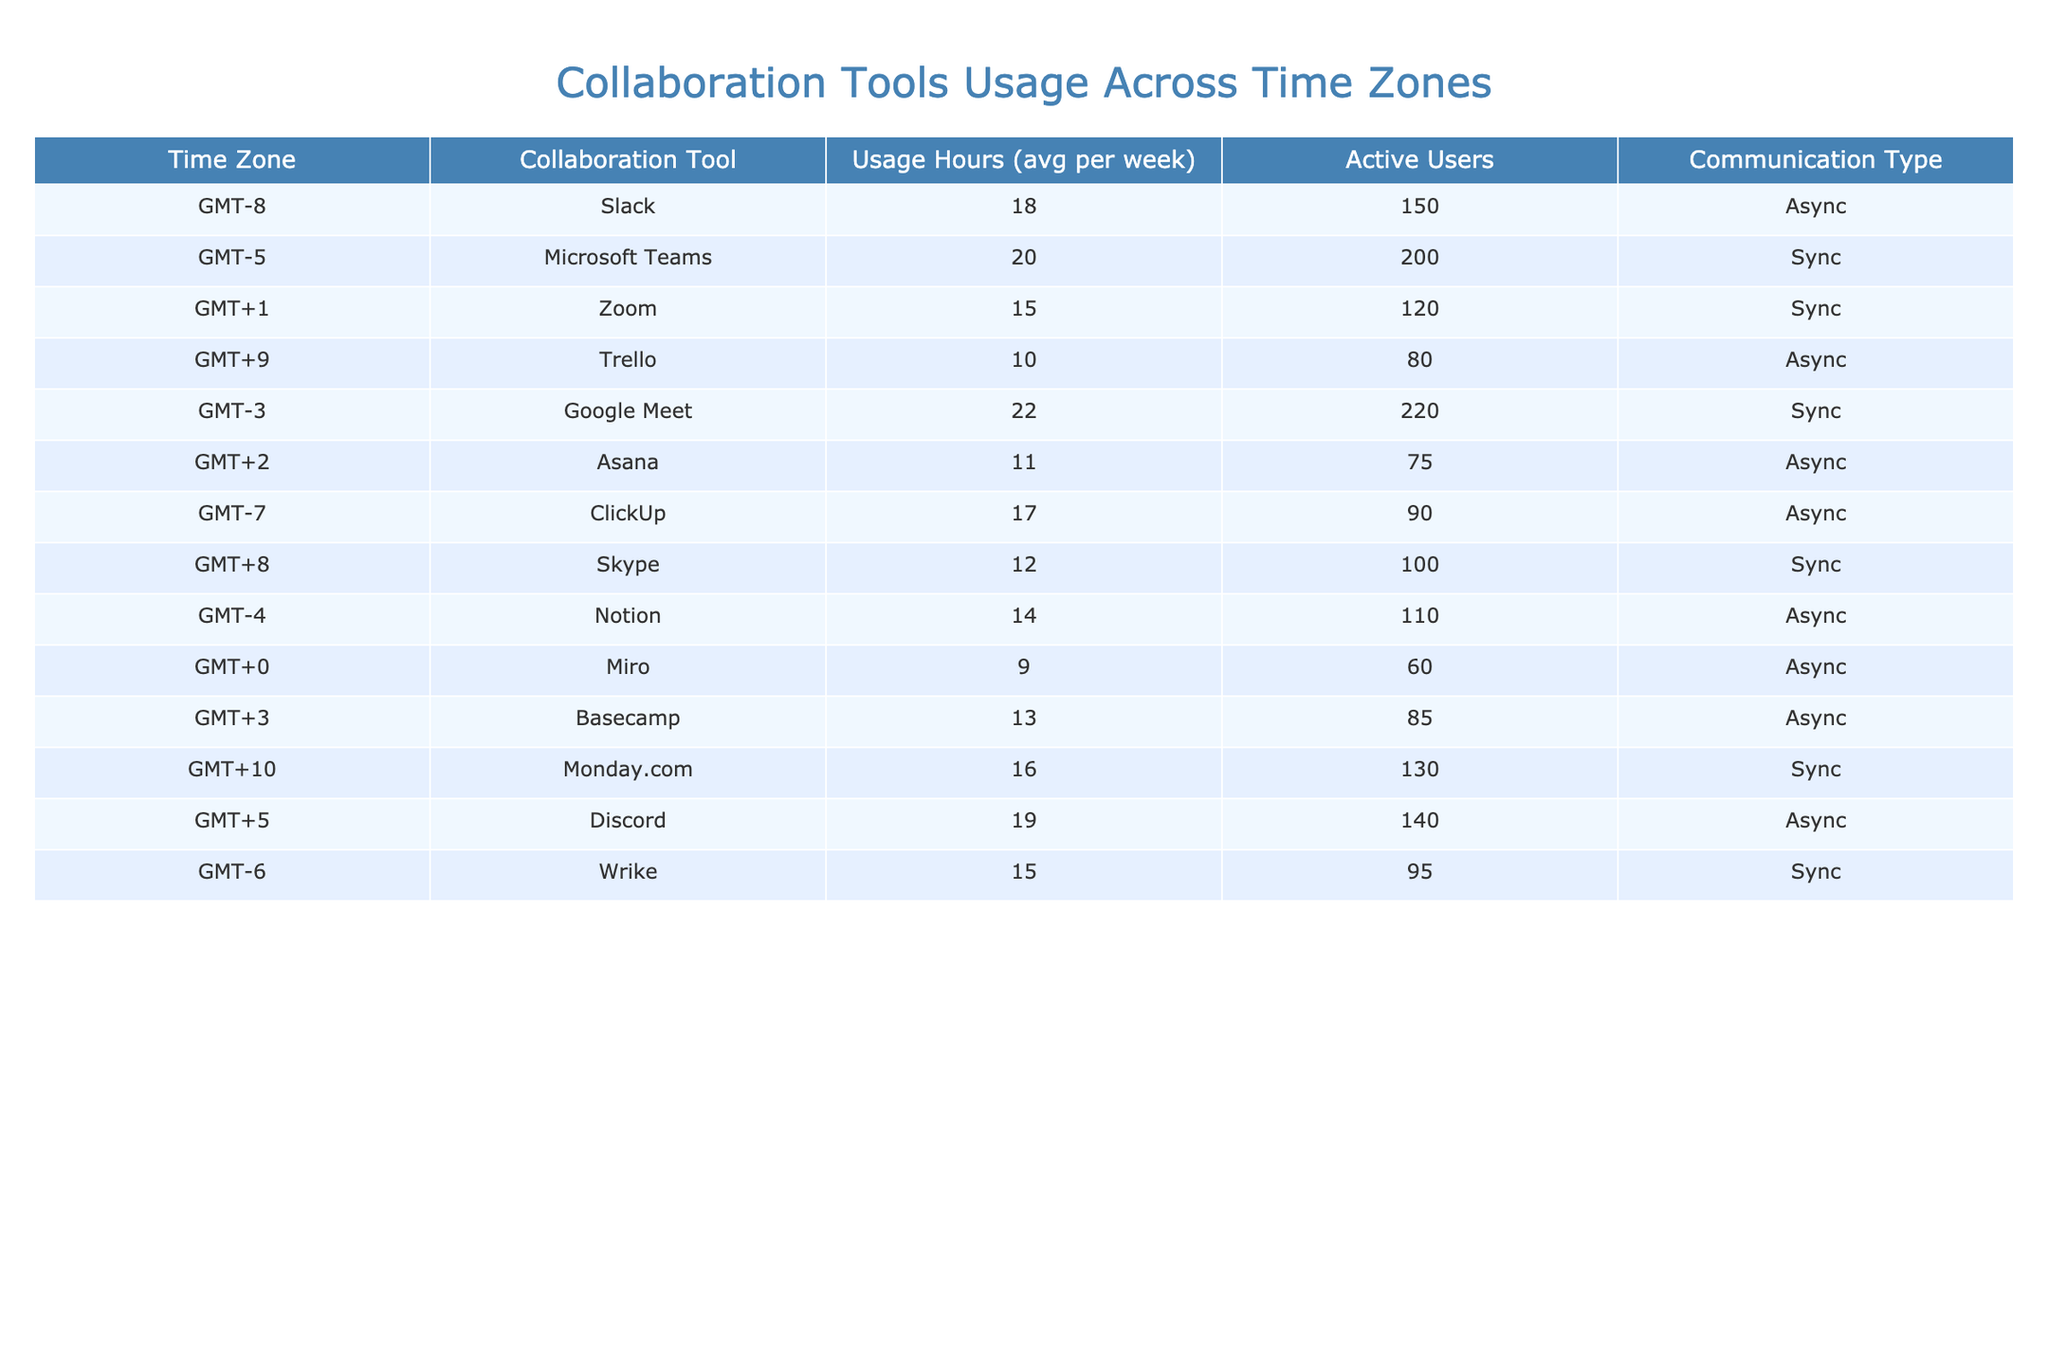What is the average usage hours for Slack in GMT-8? The table shows that the average usage hours for Slack in GMT-8 is listed as 18 hours per week.
Answer: 18 Which collaboration tool has the highest number of active users? By examining the "Active Users" column, Google Meet has the highest number of active users at 220.
Answer: Google Meet How many total active users are there for all collaboration tools in GMT-5 and GMT-3 combined? The total active users in GMT-5 (Microsoft Teams) is 200, and in GMT-3 (Google Meet) is 220. So, 200 + 220 = 420.
Answer: 420 Which time zone has the lowest average usage hours and what is that value? By reviewing the "Usage Hours" column, Miro in GMT+0 shows the lowest average usage at 9 hours per week.
Answer: 9 Is there a collaboration tool used in more than one time zone? Reviewing the "Collaboration Tool" column, none of the tools appear in more than one time zone.
Answer: No What is the total average usage hours for all collaboration tools in the GMT-6 to GMT+2 time zones? The tools and their hours are: Wrike (15), Asana (11), Google Meet (22), and Zoom (15). Adding these gives 15 + 11 + 22 + 15 = 63.
Answer: 63 Which collaboration tool has the most usage hours and is it a synchronous or asynchronous tool? The tool with the most usage hours is Google Meet at 22 hours, which is a synchronous tool.
Answer: Google Meet, Sync Which time zone has higher usage hours, GMT-7 or GMT-5, and by how much? GMT-7 (ClickUp) has 17 usage hours and GMT-5 (Microsoft Teams) has 20. Thus, 20 - 17 = 3 more usage hours in GMT-5.
Answer: GMT-5, 3 hours What is the average number of active users for asynchronous collaboration tools? The table lists the active users for asynchronous tools: Trello (80), ClickUp (90), Asana (75), Notion (110), Basecamp (85), Discord (140), giving a sum of 80 + 90 + 75 + 110 + 85 + 140 = 580. There are 6 tools, so the average is 580/6=96.67.
Answer: 96.67 Is the majority of the collaboration tools used for synchronous or asynchronous communication? From the table, there are 5 synchronous tools (Microsoft Teams, Zoom, Google Meet, Skype, Monday.com) and 7 asynchronous tools, indicating that the majority are asynchronous.
Answer: Yes, asynchronous 